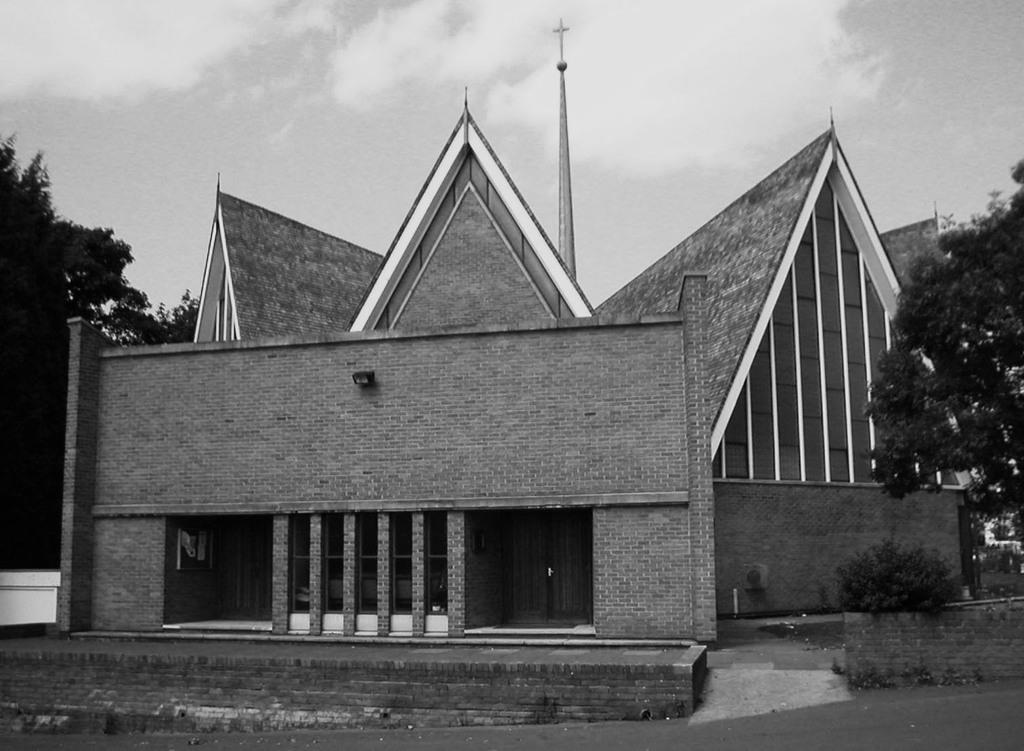What is the main structure in the image? There is a building in the image. What can be seen near the building? There are many trees next to the building. What is visible in the background of the image? There are clouds and the sky visible in the background. What type of hat is the tree wearing in the image? There are no hats present in the image, as trees do not wear hats. 